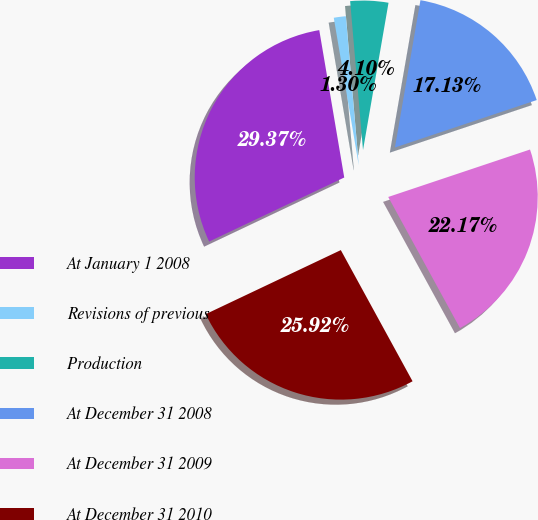Convert chart to OTSL. <chart><loc_0><loc_0><loc_500><loc_500><pie_chart><fcel>At January 1 2008<fcel>Revisions of previous<fcel>Production<fcel>At December 31 2008<fcel>At December 31 2009<fcel>At December 31 2010<nl><fcel>29.37%<fcel>1.3%<fcel>4.1%<fcel>17.13%<fcel>22.17%<fcel>25.92%<nl></chart> 